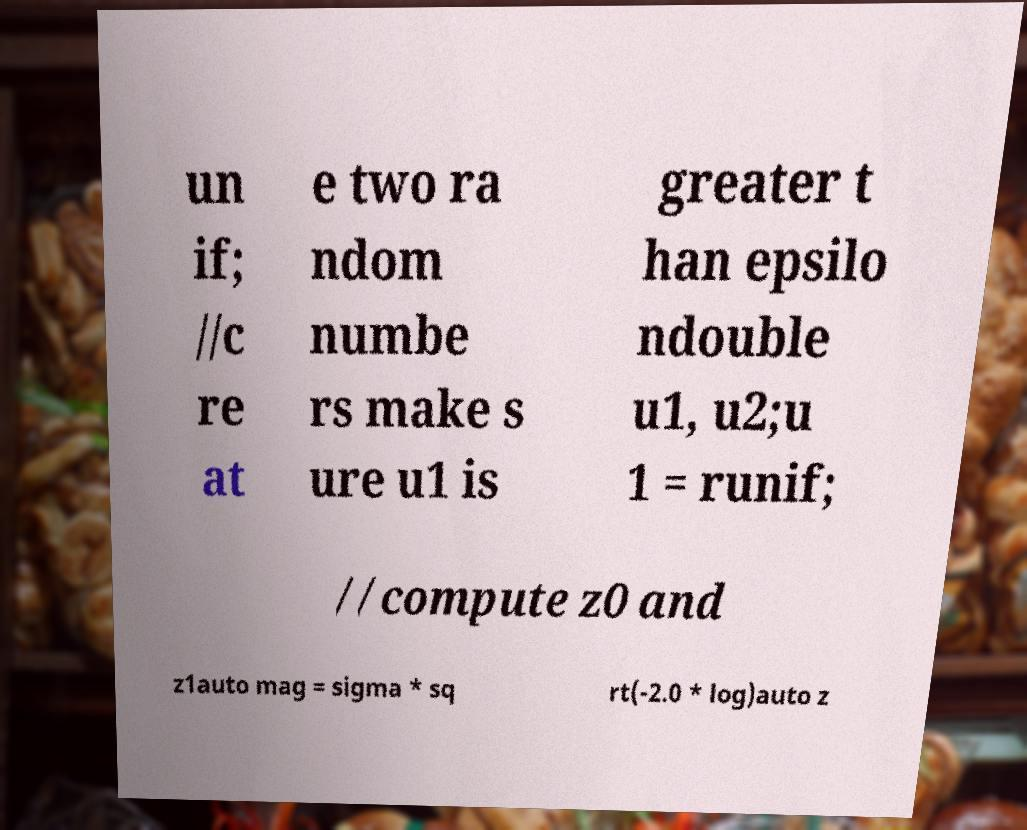There's text embedded in this image that I need extracted. Can you transcribe it verbatim? un if; //c re at e two ra ndom numbe rs make s ure u1 is greater t han epsilo ndouble u1, u2;u 1 = runif; //compute z0 and z1auto mag = sigma * sq rt(-2.0 * log)auto z 